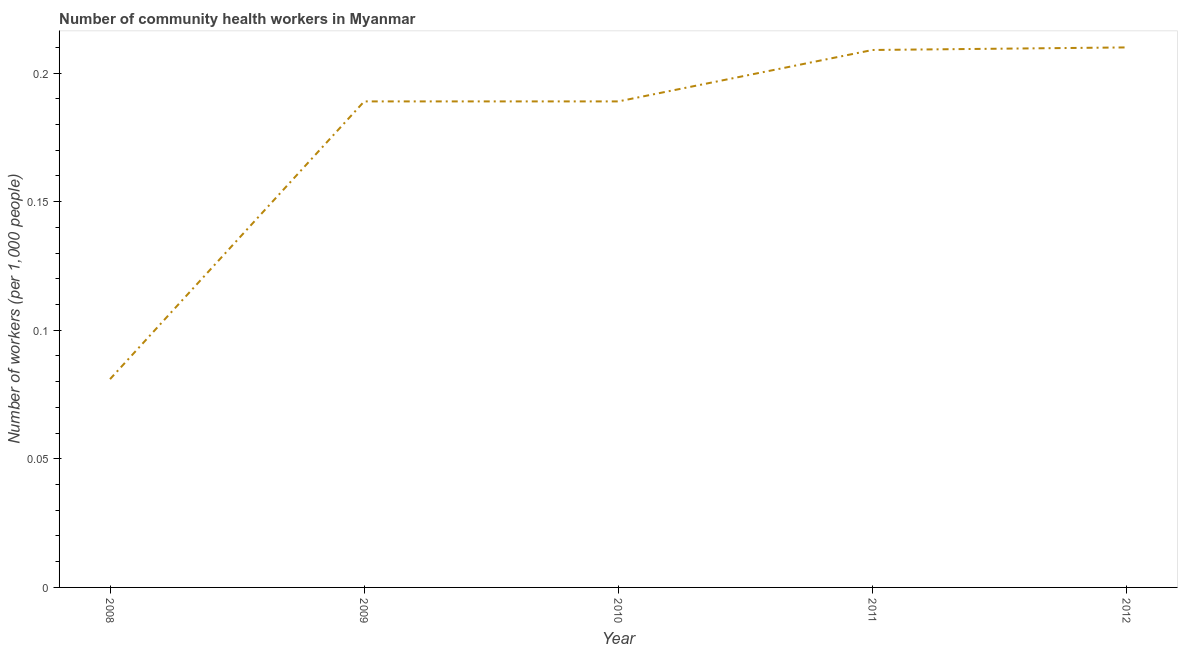What is the number of community health workers in 2008?
Provide a short and direct response. 0.08. Across all years, what is the maximum number of community health workers?
Ensure brevity in your answer.  0.21. Across all years, what is the minimum number of community health workers?
Your answer should be compact. 0.08. In which year was the number of community health workers maximum?
Your answer should be compact. 2012. In which year was the number of community health workers minimum?
Provide a succinct answer. 2008. What is the sum of the number of community health workers?
Offer a very short reply. 0.88. What is the difference between the number of community health workers in 2011 and 2012?
Keep it short and to the point. -0. What is the average number of community health workers per year?
Make the answer very short. 0.18. What is the median number of community health workers?
Your response must be concise. 0.19. In how many years, is the number of community health workers greater than 0.04 ?
Your answer should be very brief. 5. Do a majority of the years between 2012 and 2008 (inclusive) have number of community health workers greater than 0.02 ?
Your answer should be very brief. Yes. What is the ratio of the number of community health workers in 2008 to that in 2011?
Offer a terse response. 0.39. What is the difference between the highest and the second highest number of community health workers?
Provide a succinct answer. 0. What is the difference between the highest and the lowest number of community health workers?
Provide a short and direct response. 0.13. Does the number of community health workers monotonically increase over the years?
Offer a terse response. No. How many years are there in the graph?
Keep it short and to the point. 5. Are the values on the major ticks of Y-axis written in scientific E-notation?
Your answer should be compact. No. Does the graph contain any zero values?
Your answer should be compact. No. What is the title of the graph?
Ensure brevity in your answer.  Number of community health workers in Myanmar. What is the label or title of the Y-axis?
Make the answer very short. Number of workers (per 1,0 people). What is the Number of workers (per 1,000 people) in 2008?
Give a very brief answer. 0.08. What is the Number of workers (per 1,000 people) of 2009?
Offer a terse response. 0.19. What is the Number of workers (per 1,000 people) of 2010?
Make the answer very short. 0.19. What is the Number of workers (per 1,000 people) in 2011?
Offer a very short reply. 0.21. What is the Number of workers (per 1,000 people) of 2012?
Offer a very short reply. 0.21. What is the difference between the Number of workers (per 1,000 people) in 2008 and 2009?
Ensure brevity in your answer.  -0.11. What is the difference between the Number of workers (per 1,000 people) in 2008 and 2010?
Provide a succinct answer. -0.11. What is the difference between the Number of workers (per 1,000 people) in 2008 and 2011?
Provide a short and direct response. -0.13. What is the difference between the Number of workers (per 1,000 people) in 2008 and 2012?
Make the answer very short. -0.13. What is the difference between the Number of workers (per 1,000 people) in 2009 and 2010?
Give a very brief answer. 0. What is the difference between the Number of workers (per 1,000 people) in 2009 and 2011?
Offer a terse response. -0.02. What is the difference between the Number of workers (per 1,000 people) in 2009 and 2012?
Provide a short and direct response. -0.02. What is the difference between the Number of workers (per 1,000 people) in 2010 and 2011?
Give a very brief answer. -0.02. What is the difference between the Number of workers (per 1,000 people) in 2010 and 2012?
Give a very brief answer. -0.02. What is the difference between the Number of workers (per 1,000 people) in 2011 and 2012?
Ensure brevity in your answer.  -0. What is the ratio of the Number of workers (per 1,000 people) in 2008 to that in 2009?
Give a very brief answer. 0.43. What is the ratio of the Number of workers (per 1,000 people) in 2008 to that in 2010?
Provide a succinct answer. 0.43. What is the ratio of the Number of workers (per 1,000 people) in 2008 to that in 2011?
Offer a very short reply. 0.39. What is the ratio of the Number of workers (per 1,000 people) in 2008 to that in 2012?
Give a very brief answer. 0.39. What is the ratio of the Number of workers (per 1,000 people) in 2009 to that in 2011?
Offer a very short reply. 0.9. What is the ratio of the Number of workers (per 1,000 people) in 2010 to that in 2011?
Make the answer very short. 0.9. 